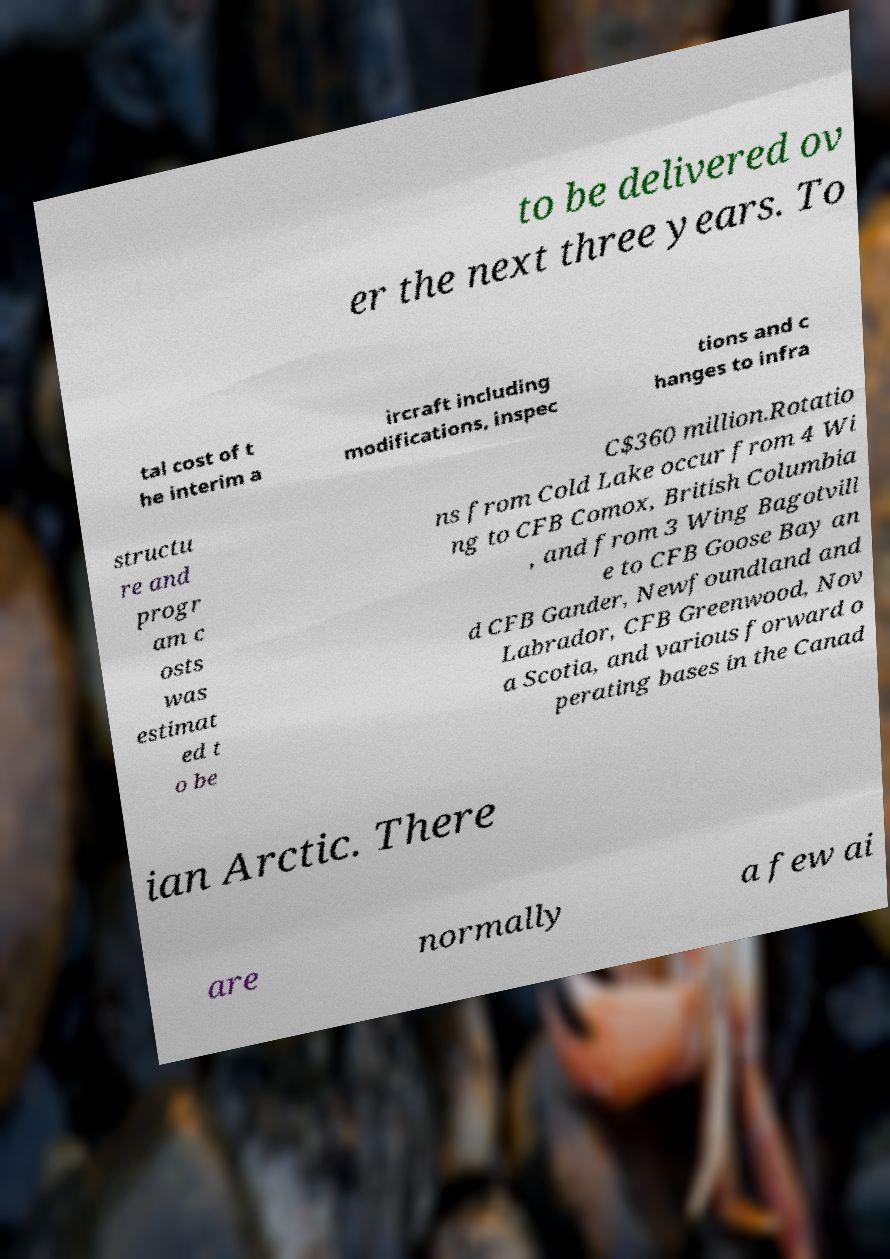Can you accurately transcribe the text from the provided image for me? to be delivered ov er the next three years. To tal cost of t he interim a ircraft including modifications, inspec tions and c hanges to infra structu re and progr am c osts was estimat ed t o be C$360 million.Rotatio ns from Cold Lake occur from 4 Wi ng to CFB Comox, British Columbia , and from 3 Wing Bagotvill e to CFB Goose Bay an d CFB Gander, Newfoundland and Labrador, CFB Greenwood, Nov a Scotia, and various forward o perating bases in the Canad ian Arctic. There are normally a few ai 